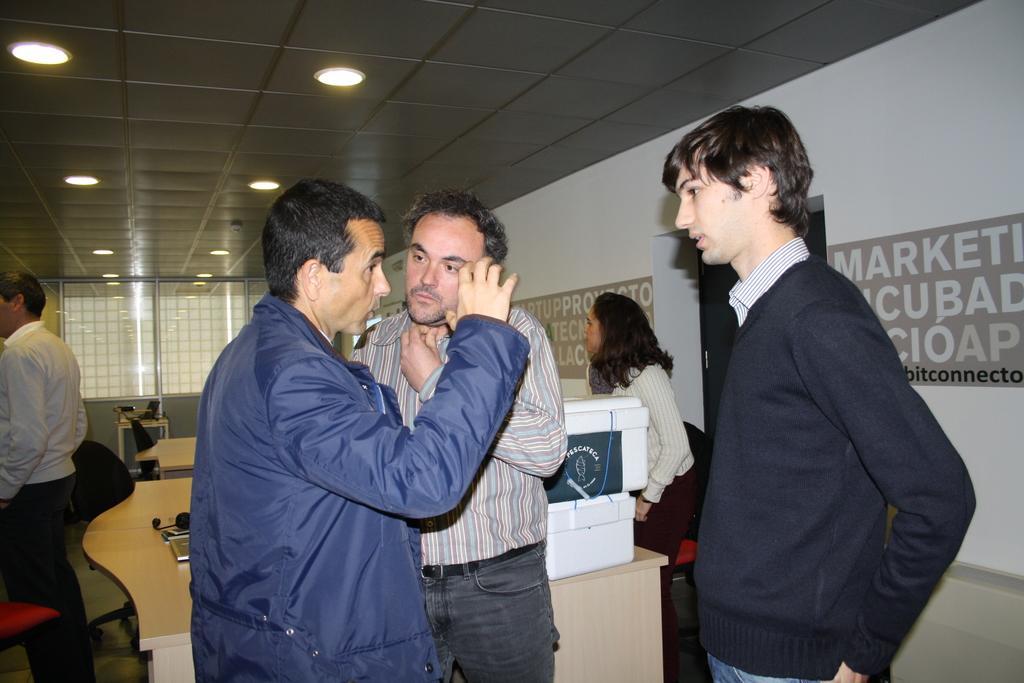Could you give a brief overview of what you see in this image? In this picture we can see a group of people standing on the floor, tables, chairs, boxes, banners on the wall and in the background we can see the lights. 